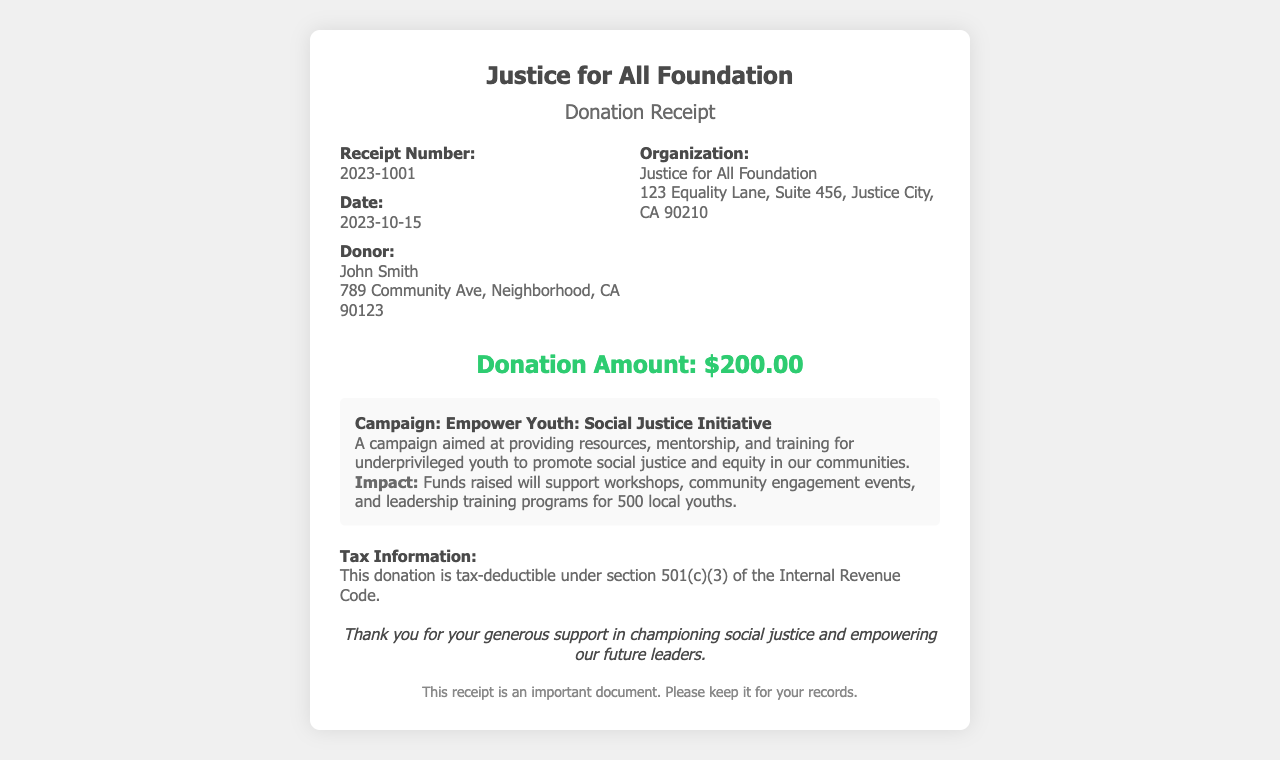What is the receipt number? The receipt number is displayed prominently within the document, identifying the specific transaction.
Answer: 2023-1001 What is the donation amount? The donation amount is listed clearly in the receipt, indicating how much was contributed.
Answer: $200.00 Who is the donor? The document specifies the name of the individual who made the donation.
Answer: John Smith What campaign is mentioned in the receipt? The campaign associated with the donation is highlighted, detailing its purpose and objective.
Answer: Empower Youth: Social Justice Initiative What is the date of the donation? The date is provided in the document, indicating when the donation was made.
Answer: 2023-10-15 What is the impact mentioned for the campaign? The impact outlines the intended benefits of the campaign, showcasing its goals and reach.
Answer: Funds raised will support workshops, community engagement events, and leadership training programs for 500 local youths Is the donation tax-deductible? Tax information is directly addressed in the receipt, clarifying the tax status of the donation.
Answer: Yes What organization received the donation? The organization that will benefit from the donation is clearly stated in the document.
Answer: Justice for All Foundation 